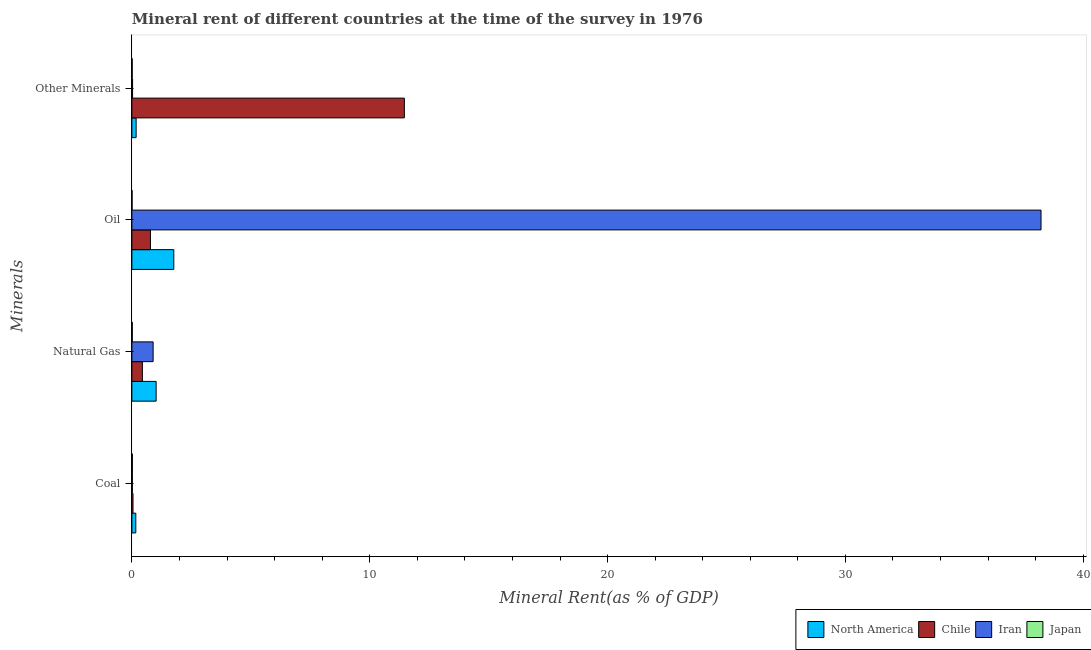Are the number of bars on each tick of the Y-axis equal?
Offer a very short reply. Yes. How many bars are there on the 2nd tick from the top?
Offer a very short reply. 4. What is the label of the 1st group of bars from the top?
Your answer should be compact. Other Minerals. What is the natural gas rent in Japan?
Provide a succinct answer. 0.02. Across all countries, what is the maximum coal rent?
Your answer should be very brief. 0.17. Across all countries, what is the minimum  rent of other minerals?
Give a very brief answer. 0.01. In which country was the oil rent maximum?
Your answer should be very brief. Iran. What is the total coal rent in the graph?
Provide a succinct answer. 0.26. What is the difference between the  rent of other minerals in Japan and that in Chile?
Make the answer very short. -11.44. What is the difference between the coal rent in North America and the  rent of other minerals in Japan?
Keep it short and to the point. 0.15. What is the average coal rent per country?
Ensure brevity in your answer.  0.06. What is the difference between the  rent of other minerals and coal rent in North America?
Your answer should be very brief. 0.01. What is the ratio of the natural gas rent in Iran to that in Japan?
Ensure brevity in your answer.  49.36. Is the difference between the  rent of other minerals in Iran and Japan greater than the difference between the oil rent in Iran and Japan?
Your response must be concise. No. What is the difference between the highest and the second highest oil rent?
Your answer should be compact. 36.46. What is the difference between the highest and the lowest natural gas rent?
Offer a very short reply. 1. What does the 3rd bar from the bottom in Oil represents?
Your answer should be compact. Iran. Are the values on the major ticks of X-axis written in scientific E-notation?
Your response must be concise. No. Does the graph contain grids?
Ensure brevity in your answer.  No. How many legend labels are there?
Offer a terse response. 4. How are the legend labels stacked?
Give a very brief answer. Horizontal. What is the title of the graph?
Give a very brief answer. Mineral rent of different countries at the time of the survey in 1976. Does "Liberia" appear as one of the legend labels in the graph?
Provide a succinct answer. No. What is the label or title of the X-axis?
Offer a very short reply. Mineral Rent(as % of GDP). What is the label or title of the Y-axis?
Make the answer very short. Minerals. What is the Mineral Rent(as % of GDP) in North America in Coal?
Provide a short and direct response. 0.17. What is the Mineral Rent(as % of GDP) in Chile in Coal?
Give a very brief answer. 0.05. What is the Mineral Rent(as % of GDP) of Iran in Coal?
Give a very brief answer. 0.02. What is the Mineral Rent(as % of GDP) of Japan in Coal?
Provide a succinct answer. 0.02. What is the Mineral Rent(as % of GDP) in North America in Natural Gas?
Offer a terse response. 1.02. What is the Mineral Rent(as % of GDP) of Chile in Natural Gas?
Make the answer very short. 0.44. What is the Mineral Rent(as % of GDP) in Iran in Natural Gas?
Offer a very short reply. 0.89. What is the Mineral Rent(as % of GDP) of Japan in Natural Gas?
Make the answer very short. 0.02. What is the Mineral Rent(as % of GDP) in North America in Oil?
Your answer should be compact. 1.76. What is the Mineral Rent(as % of GDP) of Chile in Oil?
Give a very brief answer. 0.78. What is the Mineral Rent(as % of GDP) in Iran in Oil?
Ensure brevity in your answer.  38.22. What is the Mineral Rent(as % of GDP) in Japan in Oil?
Provide a succinct answer. 0.01. What is the Mineral Rent(as % of GDP) in North America in Other Minerals?
Offer a very short reply. 0.18. What is the Mineral Rent(as % of GDP) in Chile in Other Minerals?
Offer a terse response. 11.46. What is the Mineral Rent(as % of GDP) of Iran in Other Minerals?
Keep it short and to the point. 0.03. What is the Mineral Rent(as % of GDP) of Japan in Other Minerals?
Make the answer very short. 0.01. Across all Minerals, what is the maximum Mineral Rent(as % of GDP) in North America?
Keep it short and to the point. 1.76. Across all Minerals, what is the maximum Mineral Rent(as % of GDP) in Chile?
Your response must be concise. 11.46. Across all Minerals, what is the maximum Mineral Rent(as % of GDP) of Iran?
Keep it short and to the point. 38.22. Across all Minerals, what is the maximum Mineral Rent(as % of GDP) of Japan?
Your answer should be very brief. 0.02. Across all Minerals, what is the minimum Mineral Rent(as % of GDP) in North America?
Provide a succinct answer. 0.17. Across all Minerals, what is the minimum Mineral Rent(as % of GDP) in Chile?
Make the answer very short. 0.05. Across all Minerals, what is the minimum Mineral Rent(as % of GDP) in Iran?
Your answer should be very brief. 0.02. Across all Minerals, what is the minimum Mineral Rent(as % of GDP) in Japan?
Your answer should be very brief. 0.01. What is the total Mineral Rent(as % of GDP) of North America in the graph?
Make the answer very short. 3.13. What is the total Mineral Rent(as % of GDP) of Chile in the graph?
Provide a short and direct response. 12.73. What is the total Mineral Rent(as % of GDP) of Iran in the graph?
Your answer should be very brief. 39.17. What is the total Mineral Rent(as % of GDP) in Japan in the graph?
Give a very brief answer. 0.06. What is the difference between the Mineral Rent(as % of GDP) of North America in Coal and that in Natural Gas?
Keep it short and to the point. -0.85. What is the difference between the Mineral Rent(as % of GDP) of Chile in Coal and that in Natural Gas?
Provide a succinct answer. -0.39. What is the difference between the Mineral Rent(as % of GDP) of Iran in Coal and that in Natural Gas?
Provide a short and direct response. -0.87. What is the difference between the Mineral Rent(as % of GDP) in Japan in Coal and that in Natural Gas?
Your response must be concise. 0. What is the difference between the Mineral Rent(as % of GDP) in North America in Coal and that in Oil?
Provide a short and direct response. -1.6. What is the difference between the Mineral Rent(as % of GDP) of Chile in Coal and that in Oil?
Keep it short and to the point. -0.73. What is the difference between the Mineral Rent(as % of GDP) in Iran in Coal and that in Oil?
Your answer should be compact. -38.2. What is the difference between the Mineral Rent(as % of GDP) in Japan in Coal and that in Oil?
Your answer should be compact. 0.01. What is the difference between the Mineral Rent(as % of GDP) of North America in Coal and that in Other Minerals?
Provide a short and direct response. -0.01. What is the difference between the Mineral Rent(as % of GDP) of Chile in Coal and that in Other Minerals?
Provide a succinct answer. -11.41. What is the difference between the Mineral Rent(as % of GDP) in Iran in Coal and that in Other Minerals?
Ensure brevity in your answer.  -0.01. What is the difference between the Mineral Rent(as % of GDP) in Japan in Coal and that in Other Minerals?
Provide a succinct answer. 0.01. What is the difference between the Mineral Rent(as % of GDP) in North America in Natural Gas and that in Oil?
Your answer should be compact. -0.74. What is the difference between the Mineral Rent(as % of GDP) of Chile in Natural Gas and that in Oil?
Provide a succinct answer. -0.34. What is the difference between the Mineral Rent(as % of GDP) in Iran in Natural Gas and that in Oil?
Give a very brief answer. -37.33. What is the difference between the Mineral Rent(as % of GDP) in Japan in Natural Gas and that in Oil?
Provide a short and direct response. 0.01. What is the difference between the Mineral Rent(as % of GDP) of North America in Natural Gas and that in Other Minerals?
Your response must be concise. 0.84. What is the difference between the Mineral Rent(as % of GDP) of Chile in Natural Gas and that in Other Minerals?
Offer a very short reply. -11.01. What is the difference between the Mineral Rent(as % of GDP) in Iran in Natural Gas and that in Other Minerals?
Provide a short and direct response. 0.86. What is the difference between the Mineral Rent(as % of GDP) in Japan in Natural Gas and that in Other Minerals?
Offer a terse response. 0. What is the difference between the Mineral Rent(as % of GDP) of North America in Oil and that in Other Minerals?
Offer a very short reply. 1.58. What is the difference between the Mineral Rent(as % of GDP) in Chile in Oil and that in Other Minerals?
Your answer should be compact. -10.67. What is the difference between the Mineral Rent(as % of GDP) of Iran in Oil and that in Other Minerals?
Offer a very short reply. 38.19. What is the difference between the Mineral Rent(as % of GDP) of Japan in Oil and that in Other Minerals?
Provide a succinct answer. -0.01. What is the difference between the Mineral Rent(as % of GDP) in North America in Coal and the Mineral Rent(as % of GDP) in Chile in Natural Gas?
Keep it short and to the point. -0.28. What is the difference between the Mineral Rent(as % of GDP) of North America in Coal and the Mineral Rent(as % of GDP) of Iran in Natural Gas?
Give a very brief answer. -0.73. What is the difference between the Mineral Rent(as % of GDP) in North America in Coal and the Mineral Rent(as % of GDP) in Japan in Natural Gas?
Your response must be concise. 0.15. What is the difference between the Mineral Rent(as % of GDP) in Chile in Coal and the Mineral Rent(as % of GDP) in Iran in Natural Gas?
Provide a short and direct response. -0.85. What is the difference between the Mineral Rent(as % of GDP) of Chile in Coal and the Mineral Rent(as % of GDP) of Japan in Natural Gas?
Provide a short and direct response. 0.03. What is the difference between the Mineral Rent(as % of GDP) in Iran in Coal and the Mineral Rent(as % of GDP) in Japan in Natural Gas?
Your answer should be compact. 0. What is the difference between the Mineral Rent(as % of GDP) of North America in Coal and the Mineral Rent(as % of GDP) of Chile in Oil?
Offer a terse response. -0.62. What is the difference between the Mineral Rent(as % of GDP) of North America in Coal and the Mineral Rent(as % of GDP) of Iran in Oil?
Provide a short and direct response. -38.06. What is the difference between the Mineral Rent(as % of GDP) of North America in Coal and the Mineral Rent(as % of GDP) of Japan in Oil?
Offer a terse response. 0.16. What is the difference between the Mineral Rent(as % of GDP) of Chile in Coal and the Mineral Rent(as % of GDP) of Iran in Oil?
Provide a succinct answer. -38.18. What is the difference between the Mineral Rent(as % of GDP) of Chile in Coal and the Mineral Rent(as % of GDP) of Japan in Oil?
Keep it short and to the point. 0.04. What is the difference between the Mineral Rent(as % of GDP) in Iran in Coal and the Mineral Rent(as % of GDP) in Japan in Oil?
Your answer should be very brief. 0.01. What is the difference between the Mineral Rent(as % of GDP) in North America in Coal and the Mineral Rent(as % of GDP) in Chile in Other Minerals?
Ensure brevity in your answer.  -11.29. What is the difference between the Mineral Rent(as % of GDP) in North America in Coal and the Mineral Rent(as % of GDP) in Iran in Other Minerals?
Offer a very short reply. 0.14. What is the difference between the Mineral Rent(as % of GDP) in North America in Coal and the Mineral Rent(as % of GDP) in Japan in Other Minerals?
Give a very brief answer. 0.15. What is the difference between the Mineral Rent(as % of GDP) of Chile in Coal and the Mineral Rent(as % of GDP) of Iran in Other Minerals?
Your response must be concise. 0.02. What is the difference between the Mineral Rent(as % of GDP) of Chile in Coal and the Mineral Rent(as % of GDP) of Japan in Other Minerals?
Your response must be concise. 0.03. What is the difference between the Mineral Rent(as % of GDP) in Iran in Coal and the Mineral Rent(as % of GDP) in Japan in Other Minerals?
Your answer should be compact. 0.01. What is the difference between the Mineral Rent(as % of GDP) in North America in Natural Gas and the Mineral Rent(as % of GDP) in Chile in Oil?
Make the answer very short. 0.24. What is the difference between the Mineral Rent(as % of GDP) in North America in Natural Gas and the Mineral Rent(as % of GDP) in Iran in Oil?
Your response must be concise. -37.2. What is the difference between the Mineral Rent(as % of GDP) of North America in Natural Gas and the Mineral Rent(as % of GDP) of Japan in Oil?
Your answer should be compact. 1.01. What is the difference between the Mineral Rent(as % of GDP) of Chile in Natural Gas and the Mineral Rent(as % of GDP) of Iran in Oil?
Your answer should be very brief. -37.78. What is the difference between the Mineral Rent(as % of GDP) of Chile in Natural Gas and the Mineral Rent(as % of GDP) of Japan in Oil?
Offer a terse response. 0.43. What is the difference between the Mineral Rent(as % of GDP) in Iran in Natural Gas and the Mineral Rent(as % of GDP) in Japan in Oil?
Keep it short and to the point. 0.89. What is the difference between the Mineral Rent(as % of GDP) in North America in Natural Gas and the Mineral Rent(as % of GDP) in Chile in Other Minerals?
Make the answer very short. -10.44. What is the difference between the Mineral Rent(as % of GDP) in North America in Natural Gas and the Mineral Rent(as % of GDP) in Iran in Other Minerals?
Offer a very short reply. 0.99. What is the difference between the Mineral Rent(as % of GDP) of North America in Natural Gas and the Mineral Rent(as % of GDP) of Japan in Other Minerals?
Your answer should be compact. 1.01. What is the difference between the Mineral Rent(as % of GDP) of Chile in Natural Gas and the Mineral Rent(as % of GDP) of Iran in Other Minerals?
Your answer should be compact. 0.41. What is the difference between the Mineral Rent(as % of GDP) in Chile in Natural Gas and the Mineral Rent(as % of GDP) in Japan in Other Minerals?
Keep it short and to the point. 0.43. What is the difference between the Mineral Rent(as % of GDP) of Iran in Natural Gas and the Mineral Rent(as % of GDP) of Japan in Other Minerals?
Ensure brevity in your answer.  0.88. What is the difference between the Mineral Rent(as % of GDP) in North America in Oil and the Mineral Rent(as % of GDP) in Chile in Other Minerals?
Provide a succinct answer. -9.69. What is the difference between the Mineral Rent(as % of GDP) in North America in Oil and the Mineral Rent(as % of GDP) in Iran in Other Minerals?
Make the answer very short. 1.73. What is the difference between the Mineral Rent(as % of GDP) of North America in Oil and the Mineral Rent(as % of GDP) of Japan in Other Minerals?
Ensure brevity in your answer.  1.75. What is the difference between the Mineral Rent(as % of GDP) of Chile in Oil and the Mineral Rent(as % of GDP) of Iran in Other Minerals?
Offer a very short reply. 0.75. What is the difference between the Mineral Rent(as % of GDP) of Chile in Oil and the Mineral Rent(as % of GDP) of Japan in Other Minerals?
Provide a short and direct response. 0.77. What is the difference between the Mineral Rent(as % of GDP) of Iran in Oil and the Mineral Rent(as % of GDP) of Japan in Other Minerals?
Give a very brief answer. 38.21. What is the average Mineral Rent(as % of GDP) of North America per Minerals?
Your answer should be compact. 0.78. What is the average Mineral Rent(as % of GDP) of Chile per Minerals?
Give a very brief answer. 3.18. What is the average Mineral Rent(as % of GDP) in Iran per Minerals?
Keep it short and to the point. 9.79. What is the average Mineral Rent(as % of GDP) in Japan per Minerals?
Offer a very short reply. 0.02. What is the difference between the Mineral Rent(as % of GDP) of North America and Mineral Rent(as % of GDP) of Chile in Coal?
Make the answer very short. 0.12. What is the difference between the Mineral Rent(as % of GDP) in North America and Mineral Rent(as % of GDP) in Iran in Coal?
Provide a succinct answer. 0.14. What is the difference between the Mineral Rent(as % of GDP) in North America and Mineral Rent(as % of GDP) in Japan in Coal?
Give a very brief answer. 0.14. What is the difference between the Mineral Rent(as % of GDP) in Chile and Mineral Rent(as % of GDP) in Iran in Coal?
Your answer should be very brief. 0.03. What is the difference between the Mineral Rent(as % of GDP) of Chile and Mineral Rent(as % of GDP) of Japan in Coal?
Provide a short and direct response. 0.03. What is the difference between the Mineral Rent(as % of GDP) of Iran and Mineral Rent(as % of GDP) of Japan in Coal?
Your answer should be compact. -0. What is the difference between the Mineral Rent(as % of GDP) in North America and Mineral Rent(as % of GDP) in Chile in Natural Gas?
Provide a succinct answer. 0.58. What is the difference between the Mineral Rent(as % of GDP) in North America and Mineral Rent(as % of GDP) in Iran in Natural Gas?
Provide a succinct answer. 0.13. What is the difference between the Mineral Rent(as % of GDP) of Chile and Mineral Rent(as % of GDP) of Iran in Natural Gas?
Ensure brevity in your answer.  -0.45. What is the difference between the Mineral Rent(as % of GDP) of Chile and Mineral Rent(as % of GDP) of Japan in Natural Gas?
Your answer should be compact. 0.42. What is the difference between the Mineral Rent(as % of GDP) of Iran and Mineral Rent(as % of GDP) of Japan in Natural Gas?
Give a very brief answer. 0.88. What is the difference between the Mineral Rent(as % of GDP) in North America and Mineral Rent(as % of GDP) in Chile in Oil?
Offer a terse response. 0.98. What is the difference between the Mineral Rent(as % of GDP) in North America and Mineral Rent(as % of GDP) in Iran in Oil?
Your answer should be compact. -36.46. What is the difference between the Mineral Rent(as % of GDP) in North America and Mineral Rent(as % of GDP) in Japan in Oil?
Offer a very short reply. 1.75. What is the difference between the Mineral Rent(as % of GDP) of Chile and Mineral Rent(as % of GDP) of Iran in Oil?
Make the answer very short. -37.44. What is the difference between the Mineral Rent(as % of GDP) in Chile and Mineral Rent(as % of GDP) in Japan in Oil?
Provide a succinct answer. 0.77. What is the difference between the Mineral Rent(as % of GDP) of Iran and Mineral Rent(as % of GDP) of Japan in Oil?
Your answer should be compact. 38.22. What is the difference between the Mineral Rent(as % of GDP) of North America and Mineral Rent(as % of GDP) of Chile in Other Minerals?
Your answer should be very brief. -11.28. What is the difference between the Mineral Rent(as % of GDP) of North America and Mineral Rent(as % of GDP) of Iran in Other Minerals?
Provide a succinct answer. 0.15. What is the difference between the Mineral Rent(as % of GDP) of North America and Mineral Rent(as % of GDP) of Japan in Other Minerals?
Make the answer very short. 0.16. What is the difference between the Mineral Rent(as % of GDP) in Chile and Mineral Rent(as % of GDP) in Iran in Other Minerals?
Your answer should be compact. 11.43. What is the difference between the Mineral Rent(as % of GDP) in Chile and Mineral Rent(as % of GDP) in Japan in Other Minerals?
Make the answer very short. 11.44. What is the difference between the Mineral Rent(as % of GDP) in Iran and Mineral Rent(as % of GDP) in Japan in Other Minerals?
Offer a very short reply. 0.02. What is the ratio of the Mineral Rent(as % of GDP) of North America in Coal to that in Natural Gas?
Give a very brief answer. 0.16. What is the ratio of the Mineral Rent(as % of GDP) in Chile in Coal to that in Natural Gas?
Your answer should be compact. 0.11. What is the ratio of the Mineral Rent(as % of GDP) of Iran in Coal to that in Natural Gas?
Your answer should be very brief. 0.02. What is the ratio of the Mineral Rent(as % of GDP) in Japan in Coal to that in Natural Gas?
Your answer should be very brief. 1.2. What is the ratio of the Mineral Rent(as % of GDP) of North America in Coal to that in Oil?
Your answer should be very brief. 0.09. What is the ratio of the Mineral Rent(as % of GDP) of Chile in Coal to that in Oil?
Make the answer very short. 0.06. What is the ratio of the Mineral Rent(as % of GDP) in Iran in Coal to that in Oil?
Keep it short and to the point. 0. What is the ratio of the Mineral Rent(as % of GDP) of Japan in Coal to that in Oil?
Ensure brevity in your answer.  2.64. What is the ratio of the Mineral Rent(as % of GDP) in North America in Coal to that in Other Minerals?
Provide a short and direct response. 0.93. What is the ratio of the Mineral Rent(as % of GDP) in Chile in Coal to that in Other Minerals?
Give a very brief answer. 0. What is the ratio of the Mineral Rent(as % of GDP) in Iran in Coal to that in Other Minerals?
Provide a short and direct response. 0.69. What is the ratio of the Mineral Rent(as % of GDP) of Japan in Coal to that in Other Minerals?
Give a very brief answer. 1.5. What is the ratio of the Mineral Rent(as % of GDP) of North America in Natural Gas to that in Oil?
Your response must be concise. 0.58. What is the ratio of the Mineral Rent(as % of GDP) of Chile in Natural Gas to that in Oil?
Offer a very short reply. 0.57. What is the ratio of the Mineral Rent(as % of GDP) in Iran in Natural Gas to that in Oil?
Make the answer very short. 0.02. What is the ratio of the Mineral Rent(as % of GDP) of Japan in Natural Gas to that in Oil?
Provide a short and direct response. 2.2. What is the ratio of the Mineral Rent(as % of GDP) of North America in Natural Gas to that in Other Minerals?
Ensure brevity in your answer.  5.71. What is the ratio of the Mineral Rent(as % of GDP) in Chile in Natural Gas to that in Other Minerals?
Your response must be concise. 0.04. What is the ratio of the Mineral Rent(as % of GDP) in Iran in Natural Gas to that in Other Minerals?
Make the answer very short. 30.04. What is the ratio of the Mineral Rent(as % of GDP) of Japan in Natural Gas to that in Other Minerals?
Give a very brief answer. 1.25. What is the ratio of the Mineral Rent(as % of GDP) in North America in Oil to that in Other Minerals?
Keep it short and to the point. 9.86. What is the ratio of the Mineral Rent(as % of GDP) in Chile in Oil to that in Other Minerals?
Provide a succinct answer. 0.07. What is the ratio of the Mineral Rent(as % of GDP) of Iran in Oil to that in Other Minerals?
Your answer should be very brief. 1285.13. What is the ratio of the Mineral Rent(as % of GDP) in Japan in Oil to that in Other Minerals?
Your response must be concise. 0.57. What is the difference between the highest and the second highest Mineral Rent(as % of GDP) in North America?
Make the answer very short. 0.74. What is the difference between the highest and the second highest Mineral Rent(as % of GDP) in Chile?
Your answer should be compact. 10.67. What is the difference between the highest and the second highest Mineral Rent(as % of GDP) in Iran?
Provide a succinct answer. 37.33. What is the difference between the highest and the second highest Mineral Rent(as % of GDP) of Japan?
Give a very brief answer. 0. What is the difference between the highest and the lowest Mineral Rent(as % of GDP) in North America?
Your response must be concise. 1.6. What is the difference between the highest and the lowest Mineral Rent(as % of GDP) in Chile?
Your response must be concise. 11.41. What is the difference between the highest and the lowest Mineral Rent(as % of GDP) of Iran?
Your response must be concise. 38.2. What is the difference between the highest and the lowest Mineral Rent(as % of GDP) of Japan?
Offer a terse response. 0.01. 